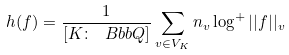Convert formula to latex. <formula><loc_0><loc_0><loc_500><loc_500>h ( f ) = \frac { 1 } { [ K \colon \ B b b { Q } ] } \sum _ { v \in V _ { K } } n _ { v } \log ^ { + } | | f | | _ { v }</formula> 